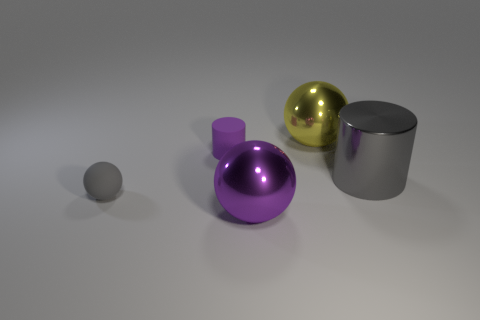What color is the large metal ball on the left side of the large metallic ball that is behind the rubber ball?
Make the answer very short. Purple. There is a large cylinder that is made of the same material as the large yellow thing; what is its color?
Offer a very short reply. Gray. How many matte things have the same color as the small matte cylinder?
Give a very brief answer. 0. What number of objects are big brown rubber cylinders or small matte objects?
Offer a very short reply. 2. There is a gray thing that is the same size as the purple rubber thing; what shape is it?
Provide a succinct answer. Sphere. How many objects are on the left side of the shiny cylinder and on the right side of the tiny purple rubber cylinder?
Your response must be concise. 2. What material is the gray thing that is left of the purple ball?
Make the answer very short. Rubber. There is another thing that is made of the same material as the tiny gray thing; what size is it?
Your answer should be compact. Small. There is a metal sphere that is in front of the yellow shiny thing; does it have the same size as the shiny ball that is on the right side of the large purple shiny thing?
Provide a short and direct response. Yes. What is the material of the object that is the same size as the matte cylinder?
Your answer should be very brief. Rubber. 